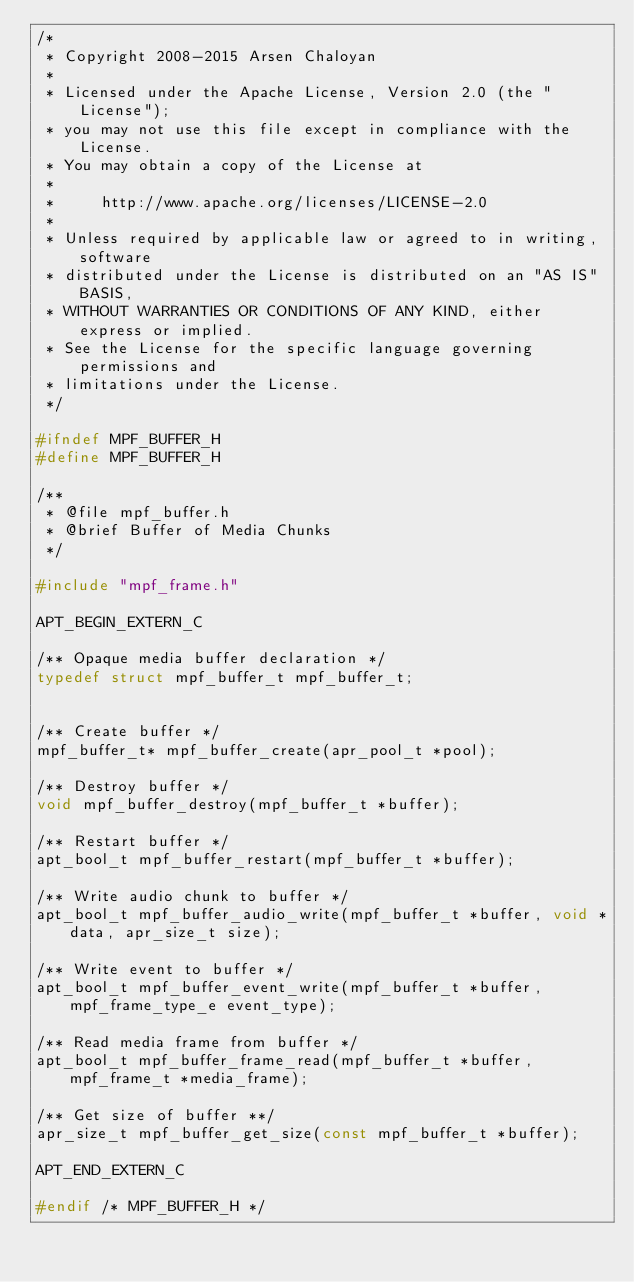<code> <loc_0><loc_0><loc_500><loc_500><_C_>/*
 * Copyright 2008-2015 Arsen Chaloyan
 *
 * Licensed under the Apache License, Version 2.0 (the "License");
 * you may not use this file except in compliance with the License.
 * You may obtain a copy of the License at
 *
 *     http://www.apache.org/licenses/LICENSE-2.0
 *
 * Unless required by applicable law or agreed to in writing, software
 * distributed under the License is distributed on an "AS IS" BASIS,
 * WITHOUT WARRANTIES OR CONDITIONS OF ANY KIND, either express or implied.
 * See the License for the specific language governing permissions and
 * limitations under the License.
 */

#ifndef MPF_BUFFER_H
#define MPF_BUFFER_H

/**
 * @file mpf_buffer.h
 * @brief Buffer of Media Chunks
 */ 

#include "mpf_frame.h"

APT_BEGIN_EXTERN_C

/** Opaque media buffer declaration */
typedef struct mpf_buffer_t mpf_buffer_t;


/** Create buffer */
mpf_buffer_t* mpf_buffer_create(apr_pool_t *pool);

/** Destroy buffer */
void mpf_buffer_destroy(mpf_buffer_t *buffer);

/** Restart buffer */
apt_bool_t mpf_buffer_restart(mpf_buffer_t *buffer);

/** Write audio chunk to buffer */
apt_bool_t mpf_buffer_audio_write(mpf_buffer_t *buffer, void *data, apr_size_t size);

/** Write event to buffer */
apt_bool_t mpf_buffer_event_write(mpf_buffer_t *buffer, mpf_frame_type_e event_type);

/** Read media frame from buffer */
apt_bool_t mpf_buffer_frame_read(mpf_buffer_t *buffer, mpf_frame_t *media_frame);

/** Get size of buffer **/
apr_size_t mpf_buffer_get_size(const mpf_buffer_t *buffer);

APT_END_EXTERN_C

#endif /* MPF_BUFFER_H */
</code> 